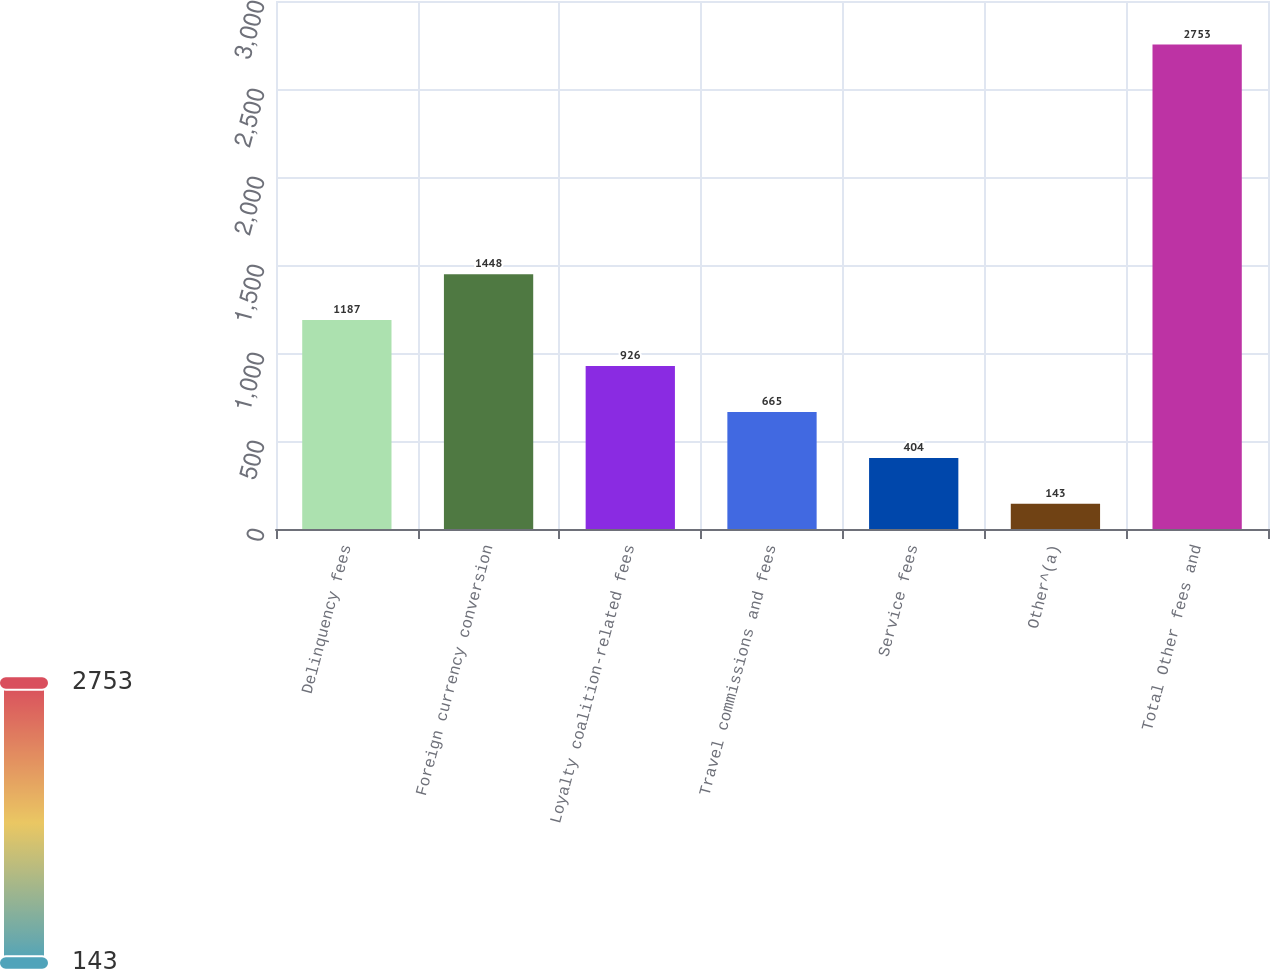<chart> <loc_0><loc_0><loc_500><loc_500><bar_chart><fcel>Delinquency fees<fcel>Foreign currency conversion<fcel>Loyalty coalition-related fees<fcel>Travel commissions and fees<fcel>Service fees<fcel>Other^(a)<fcel>Total Other fees and<nl><fcel>1187<fcel>1448<fcel>926<fcel>665<fcel>404<fcel>143<fcel>2753<nl></chart> 